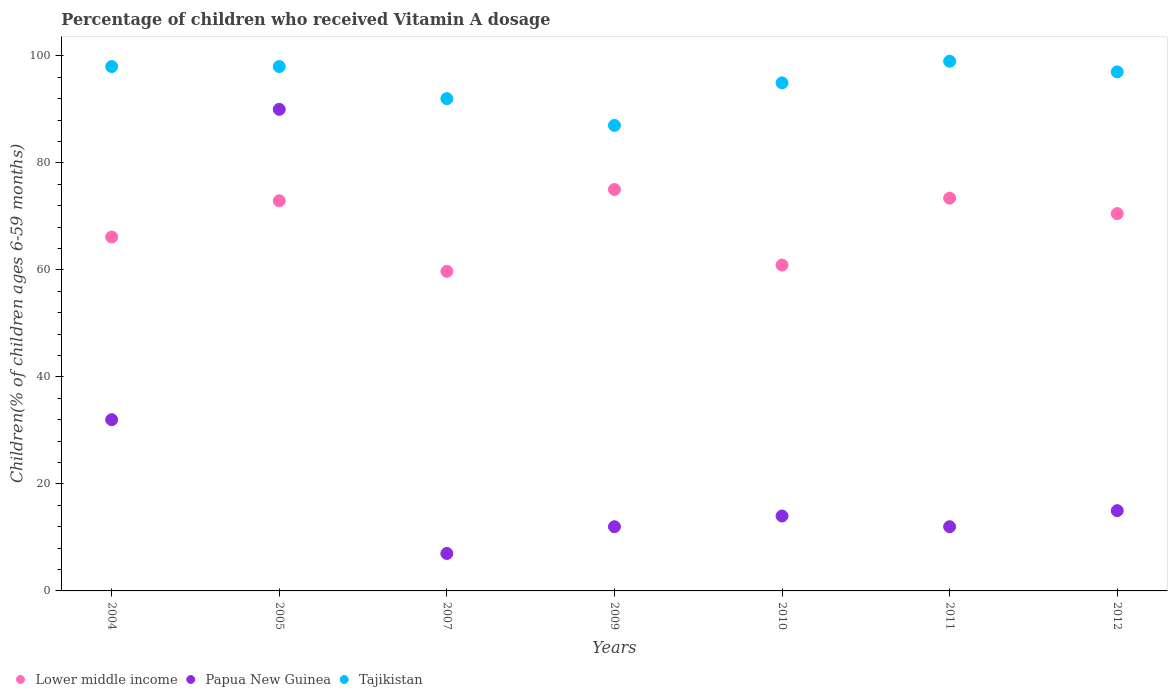What is the total percentage of children who received Vitamin A dosage in Papua New Guinea in the graph?
Provide a succinct answer. 182. What is the difference between the percentage of children who received Vitamin A dosage in Lower middle income in 2007 and that in 2012?
Ensure brevity in your answer.  -10.79. What is the difference between the percentage of children who received Vitamin A dosage in Papua New Guinea in 2011 and the percentage of children who received Vitamin A dosage in Tajikistan in 2007?
Ensure brevity in your answer.  -80. What is the average percentage of children who received Vitamin A dosage in Lower middle income per year?
Offer a terse response. 68.37. In how many years, is the percentage of children who received Vitamin A dosage in Tajikistan greater than 92 %?
Provide a short and direct response. 5. What is the ratio of the percentage of children who received Vitamin A dosage in Papua New Guinea in 2010 to that in 2012?
Provide a succinct answer. 0.93. Is the difference between the percentage of children who received Vitamin A dosage in Tajikistan in 2005 and 2010 greater than the difference between the percentage of children who received Vitamin A dosage in Papua New Guinea in 2005 and 2010?
Provide a short and direct response. No. What is the difference between the highest and the second highest percentage of children who received Vitamin A dosage in Lower middle income?
Your answer should be very brief. 1.62. What is the difference between the highest and the lowest percentage of children who received Vitamin A dosage in Papua New Guinea?
Offer a terse response. 83. In how many years, is the percentage of children who received Vitamin A dosage in Lower middle income greater than the average percentage of children who received Vitamin A dosage in Lower middle income taken over all years?
Your response must be concise. 4. Is the sum of the percentage of children who received Vitamin A dosage in Tajikistan in 2004 and 2010 greater than the maximum percentage of children who received Vitamin A dosage in Lower middle income across all years?
Your answer should be very brief. Yes. Is it the case that in every year, the sum of the percentage of children who received Vitamin A dosage in Tajikistan and percentage of children who received Vitamin A dosage in Lower middle income  is greater than the percentage of children who received Vitamin A dosage in Papua New Guinea?
Provide a succinct answer. Yes. Does the percentage of children who received Vitamin A dosage in Tajikistan monotonically increase over the years?
Provide a succinct answer. No. Is the percentage of children who received Vitamin A dosage in Papua New Guinea strictly greater than the percentage of children who received Vitamin A dosage in Lower middle income over the years?
Your answer should be compact. No. Is the percentage of children who received Vitamin A dosage in Tajikistan strictly less than the percentage of children who received Vitamin A dosage in Lower middle income over the years?
Ensure brevity in your answer.  No. How many dotlines are there?
Provide a succinct answer. 3. How many years are there in the graph?
Your answer should be compact. 7. Are the values on the major ticks of Y-axis written in scientific E-notation?
Give a very brief answer. No. Does the graph contain grids?
Your answer should be compact. No. Where does the legend appear in the graph?
Provide a short and direct response. Bottom left. What is the title of the graph?
Make the answer very short. Percentage of children who received Vitamin A dosage. Does "United Arab Emirates" appear as one of the legend labels in the graph?
Provide a succinct answer. No. What is the label or title of the X-axis?
Make the answer very short. Years. What is the label or title of the Y-axis?
Offer a terse response. Children(% of children ages 6-59 months). What is the Children(% of children ages 6-59 months) in Lower middle income in 2004?
Provide a succinct answer. 66.15. What is the Children(% of children ages 6-59 months) in Tajikistan in 2004?
Make the answer very short. 98. What is the Children(% of children ages 6-59 months) in Lower middle income in 2005?
Your answer should be compact. 72.92. What is the Children(% of children ages 6-59 months) in Lower middle income in 2007?
Your response must be concise. 59.72. What is the Children(% of children ages 6-59 months) of Papua New Guinea in 2007?
Provide a succinct answer. 7. What is the Children(% of children ages 6-59 months) in Tajikistan in 2007?
Offer a terse response. 92. What is the Children(% of children ages 6-59 months) in Lower middle income in 2009?
Make the answer very short. 75.02. What is the Children(% of children ages 6-59 months) of Lower middle income in 2010?
Give a very brief answer. 60.9. What is the Children(% of children ages 6-59 months) in Papua New Guinea in 2010?
Keep it short and to the point. 14. What is the Children(% of children ages 6-59 months) in Tajikistan in 2010?
Make the answer very short. 94.95. What is the Children(% of children ages 6-59 months) of Lower middle income in 2011?
Your response must be concise. 73.4. What is the Children(% of children ages 6-59 months) in Tajikistan in 2011?
Offer a terse response. 99. What is the Children(% of children ages 6-59 months) of Lower middle income in 2012?
Your response must be concise. 70.51. What is the Children(% of children ages 6-59 months) of Papua New Guinea in 2012?
Offer a terse response. 15. What is the Children(% of children ages 6-59 months) of Tajikistan in 2012?
Provide a short and direct response. 97. Across all years, what is the maximum Children(% of children ages 6-59 months) of Lower middle income?
Your response must be concise. 75.02. Across all years, what is the maximum Children(% of children ages 6-59 months) in Papua New Guinea?
Offer a terse response. 90. Across all years, what is the maximum Children(% of children ages 6-59 months) of Tajikistan?
Your answer should be compact. 99. Across all years, what is the minimum Children(% of children ages 6-59 months) in Lower middle income?
Your answer should be compact. 59.72. Across all years, what is the minimum Children(% of children ages 6-59 months) in Tajikistan?
Provide a short and direct response. 87. What is the total Children(% of children ages 6-59 months) in Lower middle income in the graph?
Make the answer very short. 478.62. What is the total Children(% of children ages 6-59 months) in Papua New Guinea in the graph?
Provide a short and direct response. 182. What is the total Children(% of children ages 6-59 months) in Tajikistan in the graph?
Your answer should be very brief. 665.95. What is the difference between the Children(% of children ages 6-59 months) in Lower middle income in 2004 and that in 2005?
Make the answer very short. -6.77. What is the difference between the Children(% of children ages 6-59 months) of Papua New Guinea in 2004 and that in 2005?
Offer a terse response. -58. What is the difference between the Children(% of children ages 6-59 months) of Tajikistan in 2004 and that in 2005?
Provide a short and direct response. 0. What is the difference between the Children(% of children ages 6-59 months) in Lower middle income in 2004 and that in 2007?
Make the answer very short. 6.43. What is the difference between the Children(% of children ages 6-59 months) of Papua New Guinea in 2004 and that in 2007?
Make the answer very short. 25. What is the difference between the Children(% of children ages 6-59 months) of Lower middle income in 2004 and that in 2009?
Your answer should be very brief. -8.88. What is the difference between the Children(% of children ages 6-59 months) of Tajikistan in 2004 and that in 2009?
Give a very brief answer. 11. What is the difference between the Children(% of children ages 6-59 months) of Lower middle income in 2004 and that in 2010?
Ensure brevity in your answer.  5.25. What is the difference between the Children(% of children ages 6-59 months) of Tajikistan in 2004 and that in 2010?
Offer a terse response. 3.05. What is the difference between the Children(% of children ages 6-59 months) of Lower middle income in 2004 and that in 2011?
Provide a succinct answer. -7.26. What is the difference between the Children(% of children ages 6-59 months) in Lower middle income in 2004 and that in 2012?
Ensure brevity in your answer.  -4.36. What is the difference between the Children(% of children ages 6-59 months) in Papua New Guinea in 2004 and that in 2012?
Make the answer very short. 17. What is the difference between the Children(% of children ages 6-59 months) of Lower middle income in 2005 and that in 2007?
Your response must be concise. 13.2. What is the difference between the Children(% of children ages 6-59 months) in Papua New Guinea in 2005 and that in 2007?
Offer a terse response. 83. What is the difference between the Children(% of children ages 6-59 months) of Tajikistan in 2005 and that in 2007?
Ensure brevity in your answer.  6. What is the difference between the Children(% of children ages 6-59 months) of Lower middle income in 2005 and that in 2009?
Your response must be concise. -2.11. What is the difference between the Children(% of children ages 6-59 months) in Tajikistan in 2005 and that in 2009?
Your response must be concise. 11. What is the difference between the Children(% of children ages 6-59 months) in Lower middle income in 2005 and that in 2010?
Offer a very short reply. 12.02. What is the difference between the Children(% of children ages 6-59 months) in Papua New Guinea in 2005 and that in 2010?
Your response must be concise. 76. What is the difference between the Children(% of children ages 6-59 months) in Tajikistan in 2005 and that in 2010?
Your response must be concise. 3.05. What is the difference between the Children(% of children ages 6-59 months) of Lower middle income in 2005 and that in 2011?
Your response must be concise. -0.49. What is the difference between the Children(% of children ages 6-59 months) of Tajikistan in 2005 and that in 2011?
Provide a succinct answer. -1. What is the difference between the Children(% of children ages 6-59 months) in Lower middle income in 2005 and that in 2012?
Provide a short and direct response. 2.41. What is the difference between the Children(% of children ages 6-59 months) in Papua New Guinea in 2005 and that in 2012?
Your response must be concise. 75. What is the difference between the Children(% of children ages 6-59 months) of Lower middle income in 2007 and that in 2009?
Keep it short and to the point. -15.3. What is the difference between the Children(% of children ages 6-59 months) of Lower middle income in 2007 and that in 2010?
Offer a very short reply. -1.18. What is the difference between the Children(% of children ages 6-59 months) in Tajikistan in 2007 and that in 2010?
Offer a very short reply. -2.95. What is the difference between the Children(% of children ages 6-59 months) in Lower middle income in 2007 and that in 2011?
Your response must be concise. -13.68. What is the difference between the Children(% of children ages 6-59 months) of Papua New Guinea in 2007 and that in 2011?
Offer a terse response. -5. What is the difference between the Children(% of children ages 6-59 months) of Tajikistan in 2007 and that in 2011?
Keep it short and to the point. -7. What is the difference between the Children(% of children ages 6-59 months) of Lower middle income in 2007 and that in 2012?
Ensure brevity in your answer.  -10.79. What is the difference between the Children(% of children ages 6-59 months) of Tajikistan in 2007 and that in 2012?
Offer a terse response. -5. What is the difference between the Children(% of children ages 6-59 months) of Lower middle income in 2009 and that in 2010?
Offer a very short reply. 14.13. What is the difference between the Children(% of children ages 6-59 months) of Papua New Guinea in 2009 and that in 2010?
Ensure brevity in your answer.  -2. What is the difference between the Children(% of children ages 6-59 months) in Tajikistan in 2009 and that in 2010?
Your response must be concise. -7.95. What is the difference between the Children(% of children ages 6-59 months) of Lower middle income in 2009 and that in 2011?
Offer a terse response. 1.62. What is the difference between the Children(% of children ages 6-59 months) of Papua New Guinea in 2009 and that in 2011?
Keep it short and to the point. 0. What is the difference between the Children(% of children ages 6-59 months) of Tajikistan in 2009 and that in 2011?
Make the answer very short. -12. What is the difference between the Children(% of children ages 6-59 months) in Lower middle income in 2009 and that in 2012?
Your response must be concise. 4.51. What is the difference between the Children(% of children ages 6-59 months) in Lower middle income in 2010 and that in 2011?
Offer a very short reply. -12.51. What is the difference between the Children(% of children ages 6-59 months) of Tajikistan in 2010 and that in 2011?
Offer a terse response. -4.05. What is the difference between the Children(% of children ages 6-59 months) in Lower middle income in 2010 and that in 2012?
Keep it short and to the point. -9.62. What is the difference between the Children(% of children ages 6-59 months) in Papua New Guinea in 2010 and that in 2012?
Your answer should be compact. -1. What is the difference between the Children(% of children ages 6-59 months) of Tajikistan in 2010 and that in 2012?
Keep it short and to the point. -2.05. What is the difference between the Children(% of children ages 6-59 months) in Lower middle income in 2011 and that in 2012?
Make the answer very short. 2.89. What is the difference between the Children(% of children ages 6-59 months) in Lower middle income in 2004 and the Children(% of children ages 6-59 months) in Papua New Guinea in 2005?
Give a very brief answer. -23.85. What is the difference between the Children(% of children ages 6-59 months) in Lower middle income in 2004 and the Children(% of children ages 6-59 months) in Tajikistan in 2005?
Ensure brevity in your answer.  -31.85. What is the difference between the Children(% of children ages 6-59 months) of Papua New Guinea in 2004 and the Children(% of children ages 6-59 months) of Tajikistan in 2005?
Offer a very short reply. -66. What is the difference between the Children(% of children ages 6-59 months) of Lower middle income in 2004 and the Children(% of children ages 6-59 months) of Papua New Guinea in 2007?
Your response must be concise. 59.15. What is the difference between the Children(% of children ages 6-59 months) in Lower middle income in 2004 and the Children(% of children ages 6-59 months) in Tajikistan in 2007?
Make the answer very short. -25.85. What is the difference between the Children(% of children ages 6-59 months) of Papua New Guinea in 2004 and the Children(% of children ages 6-59 months) of Tajikistan in 2007?
Provide a short and direct response. -60. What is the difference between the Children(% of children ages 6-59 months) of Lower middle income in 2004 and the Children(% of children ages 6-59 months) of Papua New Guinea in 2009?
Provide a short and direct response. 54.15. What is the difference between the Children(% of children ages 6-59 months) of Lower middle income in 2004 and the Children(% of children ages 6-59 months) of Tajikistan in 2009?
Ensure brevity in your answer.  -20.85. What is the difference between the Children(% of children ages 6-59 months) in Papua New Guinea in 2004 and the Children(% of children ages 6-59 months) in Tajikistan in 2009?
Your answer should be compact. -55. What is the difference between the Children(% of children ages 6-59 months) of Lower middle income in 2004 and the Children(% of children ages 6-59 months) of Papua New Guinea in 2010?
Keep it short and to the point. 52.15. What is the difference between the Children(% of children ages 6-59 months) of Lower middle income in 2004 and the Children(% of children ages 6-59 months) of Tajikistan in 2010?
Provide a short and direct response. -28.8. What is the difference between the Children(% of children ages 6-59 months) in Papua New Guinea in 2004 and the Children(% of children ages 6-59 months) in Tajikistan in 2010?
Ensure brevity in your answer.  -62.95. What is the difference between the Children(% of children ages 6-59 months) in Lower middle income in 2004 and the Children(% of children ages 6-59 months) in Papua New Guinea in 2011?
Offer a very short reply. 54.15. What is the difference between the Children(% of children ages 6-59 months) in Lower middle income in 2004 and the Children(% of children ages 6-59 months) in Tajikistan in 2011?
Your answer should be very brief. -32.85. What is the difference between the Children(% of children ages 6-59 months) in Papua New Guinea in 2004 and the Children(% of children ages 6-59 months) in Tajikistan in 2011?
Make the answer very short. -67. What is the difference between the Children(% of children ages 6-59 months) in Lower middle income in 2004 and the Children(% of children ages 6-59 months) in Papua New Guinea in 2012?
Your response must be concise. 51.15. What is the difference between the Children(% of children ages 6-59 months) of Lower middle income in 2004 and the Children(% of children ages 6-59 months) of Tajikistan in 2012?
Offer a very short reply. -30.85. What is the difference between the Children(% of children ages 6-59 months) of Papua New Guinea in 2004 and the Children(% of children ages 6-59 months) of Tajikistan in 2012?
Your answer should be very brief. -65. What is the difference between the Children(% of children ages 6-59 months) of Lower middle income in 2005 and the Children(% of children ages 6-59 months) of Papua New Guinea in 2007?
Your answer should be very brief. 65.92. What is the difference between the Children(% of children ages 6-59 months) of Lower middle income in 2005 and the Children(% of children ages 6-59 months) of Tajikistan in 2007?
Your answer should be compact. -19.08. What is the difference between the Children(% of children ages 6-59 months) in Lower middle income in 2005 and the Children(% of children ages 6-59 months) in Papua New Guinea in 2009?
Make the answer very short. 60.92. What is the difference between the Children(% of children ages 6-59 months) in Lower middle income in 2005 and the Children(% of children ages 6-59 months) in Tajikistan in 2009?
Your answer should be compact. -14.08. What is the difference between the Children(% of children ages 6-59 months) of Lower middle income in 2005 and the Children(% of children ages 6-59 months) of Papua New Guinea in 2010?
Ensure brevity in your answer.  58.92. What is the difference between the Children(% of children ages 6-59 months) of Lower middle income in 2005 and the Children(% of children ages 6-59 months) of Tajikistan in 2010?
Give a very brief answer. -22.03. What is the difference between the Children(% of children ages 6-59 months) in Papua New Guinea in 2005 and the Children(% of children ages 6-59 months) in Tajikistan in 2010?
Provide a short and direct response. -4.95. What is the difference between the Children(% of children ages 6-59 months) of Lower middle income in 2005 and the Children(% of children ages 6-59 months) of Papua New Guinea in 2011?
Provide a succinct answer. 60.92. What is the difference between the Children(% of children ages 6-59 months) in Lower middle income in 2005 and the Children(% of children ages 6-59 months) in Tajikistan in 2011?
Give a very brief answer. -26.08. What is the difference between the Children(% of children ages 6-59 months) of Papua New Guinea in 2005 and the Children(% of children ages 6-59 months) of Tajikistan in 2011?
Provide a short and direct response. -9. What is the difference between the Children(% of children ages 6-59 months) of Lower middle income in 2005 and the Children(% of children ages 6-59 months) of Papua New Guinea in 2012?
Provide a succinct answer. 57.92. What is the difference between the Children(% of children ages 6-59 months) in Lower middle income in 2005 and the Children(% of children ages 6-59 months) in Tajikistan in 2012?
Your response must be concise. -24.08. What is the difference between the Children(% of children ages 6-59 months) in Lower middle income in 2007 and the Children(% of children ages 6-59 months) in Papua New Guinea in 2009?
Your answer should be very brief. 47.72. What is the difference between the Children(% of children ages 6-59 months) of Lower middle income in 2007 and the Children(% of children ages 6-59 months) of Tajikistan in 2009?
Your response must be concise. -27.28. What is the difference between the Children(% of children ages 6-59 months) of Papua New Guinea in 2007 and the Children(% of children ages 6-59 months) of Tajikistan in 2009?
Your answer should be compact. -80. What is the difference between the Children(% of children ages 6-59 months) in Lower middle income in 2007 and the Children(% of children ages 6-59 months) in Papua New Guinea in 2010?
Provide a succinct answer. 45.72. What is the difference between the Children(% of children ages 6-59 months) in Lower middle income in 2007 and the Children(% of children ages 6-59 months) in Tajikistan in 2010?
Make the answer very short. -35.23. What is the difference between the Children(% of children ages 6-59 months) of Papua New Guinea in 2007 and the Children(% of children ages 6-59 months) of Tajikistan in 2010?
Ensure brevity in your answer.  -87.95. What is the difference between the Children(% of children ages 6-59 months) of Lower middle income in 2007 and the Children(% of children ages 6-59 months) of Papua New Guinea in 2011?
Give a very brief answer. 47.72. What is the difference between the Children(% of children ages 6-59 months) in Lower middle income in 2007 and the Children(% of children ages 6-59 months) in Tajikistan in 2011?
Give a very brief answer. -39.28. What is the difference between the Children(% of children ages 6-59 months) in Papua New Guinea in 2007 and the Children(% of children ages 6-59 months) in Tajikistan in 2011?
Offer a very short reply. -92. What is the difference between the Children(% of children ages 6-59 months) in Lower middle income in 2007 and the Children(% of children ages 6-59 months) in Papua New Guinea in 2012?
Your answer should be compact. 44.72. What is the difference between the Children(% of children ages 6-59 months) of Lower middle income in 2007 and the Children(% of children ages 6-59 months) of Tajikistan in 2012?
Offer a terse response. -37.28. What is the difference between the Children(% of children ages 6-59 months) in Papua New Guinea in 2007 and the Children(% of children ages 6-59 months) in Tajikistan in 2012?
Make the answer very short. -90. What is the difference between the Children(% of children ages 6-59 months) of Lower middle income in 2009 and the Children(% of children ages 6-59 months) of Papua New Guinea in 2010?
Provide a short and direct response. 61.02. What is the difference between the Children(% of children ages 6-59 months) in Lower middle income in 2009 and the Children(% of children ages 6-59 months) in Tajikistan in 2010?
Provide a short and direct response. -19.93. What is the difference between the Children(% of children ages 6-59 months) in Papua New Guinea in 2009 and the Children(% of children ages 6-59 months) in Tajikistan in 2010?
Offer a very short reply. -82.95. What is the difference between the Children(% of children ages 6-59 months) of Lower middle income in 2009 and the Children(% of children ages 6-59 months) of Papua New Guinea in 2011?
Offer a very short reply. 63.02. What is the difference between the Children(% of children ages 6-59 months) in Lower middle income in 2009 and the Children(% of children ages 6-59 months) in Tajikistan in 2011?
Offer a very short reply. -23.98. What is the difference between the Children(% of children ages 6-59 months) in Papua New Guinea in 2009 and the Children(% of children ages 6-59 months) in Tajikistan in 2011?
Provide a short and direct response. -87. What is the difference between the Children(% of children ages 6-59 months) in Lower middle income in 2009 and the Children(% of children ages 6-59 months) in Papua New Guinea in 2012?
Your answer should be very brief. 60.02. What is the difference between the Children(% of children ages 6-59 months) in Lower middle income in 2009 and the Children(% of children ages 6-59 months) in Tajikistan in 2012?
Offer a very short reply. -21.98. What is the difference between the Children(% of children ages 6-59 months) in Papua New Guinea in 2009 and the Children(% of children ages 6-59 months) in Tajikistan in 2012?
Offer a terse response. -85. What is the difference between the Children(% of children ages 6-59 months) of Lower middle income in 2010 and the Children(% of children ages 6-59 months) of Papua New Guinea in 2011?
Keep it short and to the point. 48.9. What is the difference between the Children(% of children ages 6-59 months) in Lower middle income in 2010 and the Children(% of children ages 6-59 months) in Tajikistan in 2011?
Your response must be concise. -38.1. What is the difference between the Children(% of children ages 6-59 months) in Papua New Guinea in 2010 and the Children(% of children ages 6-59 months) in Tajikistan in 2011?
Offer a very short reply. -85. What is the difference between the Children(% of children ages 6-59 months) in Lower middle income in 2010 and the Children(% of children ages 6-59 months) in Papua New Guinea in 2012?
Keep it short and to the point. 45.9. What is the difference between the Children(% of children ages 6-59 months) in Lower middle income in 2010 and the Children(% of children ages 6-59 months) in Tajikistan in 2012?
Make the answer very short. -36.1. What is the difference between the Children(% of children ages 6-59 months) of Papua New Guinea in 2010 and the Children(% of children ages 6-59 months) of Tajikistan in 2012?
Provide a short and direct response. -83. What is the difference between the Children(% of children ages 6-59 months) of Lower middle income in 2011 and the Children(% of children ages 6-59 months) of Papua New Guinea in 2012?
Ensure brevity in your answer.  58.4. What is the difference between the Children(% of children ages 6-59 months) in Lower middle income in 2011 and the Children(% of children ages 6-59 months) in Tajikistan in 2012?
Keep it short and to the point. -23.6. What is the difference between the Children(% of children ages 6-59 months) in Papua New Guinea in 2011 and the Children(% of children ages 6-59 months) in Tajikistan in 2012?
Provide a short and direct response. -85. What is the average Children(% of children ages 6-59 months) of Lower middle income per year?
Offer a terse response. 68.37. What is the average Children(% of children ages 6-59 months) of Papua New Guinea per year?
Your answer should be very brief. 26. What is the average Children(% of children ages 6-59 months) in Tajikistan per year?
Give a very brief answer. 95.14. In the year 2004, what is the difference between the Children(% of children ages 6-59 months) of Lower middle income and Children(% of children ages 6-59 months) of Papua New Guinea?
Keep it short and to the point. 34.15. In the year 2004, what is the difference between the Children(% of children ages 6-59 months) in Lower middle income and Children(% of children ages 6-59 months) in Tajikistan?
Provide a succinct answer. -31.85. In the year 2004, what is the difference between the Children(% of children ages 6-59 months) in Papua New Guinea and Children(% of children ages 6-59 months) in Tajikistan?
Ensure brevity in your answer.  -66. In the year 2005, what is the difference between the Children(% of children ages 6-59 months) of Lower middle income and Children(% of children ages 6-59 months) of Papua New Guinea?
Give a very brief answer. -17.08. In the year 2005, what is the difference between the Children(% of children ages 6-59 months) in Lower middle income and Children(% of children ages 6-59 months) in Tajikistan?
Offer a terse response. -25.08. In the year 2005, what is the difference between the Children(% of children ages 6-59 months) of Papua New Guinea and Children(% of children ages 6-59 months) of Tajikistan?
Offer a very short reply. -8. In the year 2007, what is the difference between the Children(% of children ages 6-59 months) of Lower middle income and Children(% of children ages 6-59 months) of Papua New Guinea?
Make the answer very short. 52.72. In the year 2007, what is the difference between the Children(% of children ages 6-59 months) of Lower middle income and Children(% of children ages 6-59 months) of Tajikistan?
Offer a terse response. -32.28. In the year 2007, what is the difference between the Children(% of children ages 6-59 months) of Papua New Guinea and Children(% of children ages 6-59 months) of Tajikistan?
Keep it short and to the point. -85. In the year 2009, what is the difference between the Children(% of children ages 6-59 months) of Lower middle income and Children(% of children ages 6-59 months) of Papua New Guinea?
Offer a very short reply. 63.02. In the year 2009, what is the difference between the Children(% of children ages 6-59 months) in Lower middle income and Children(% of children ages 6-59 months) in Tajikistan?
Your answer should be very brief. -11.98. In the year 2009, what is the difference between the Children(% of children ages 6-59 months) of Papua New Guinea and Children(% of children ages 6-59 months) of Tajikistan?
Your answer should be very brief. -75. In the year 2010, what is the difference between the Children(% of children ages 6-59 months) of Lower middle income and Children(% of children ages 6-59 months) of Papua New Guinea?
Give a very brief answer. 46.9. In the year 2010, what is the difference between the Children(% of children ages 6-59 months) of Lower middle income and Children(% of children ages 6-59 months) of Tajikistan?
Keep it short and to the point. -34.05. In the year 2010, what is the difference between the Children(% of children ages 6-59 months) in Papua New Guinea and Children(% of children ages 6-59 months) in Tajikistan?
Keep it short and to the point. -80.95. In the year 2011, what is the difference between the Children(% of children ages 6-59 months) in Lower middle income and Children(% of children ages 6-59 months) in Papua New Guinea?
Your answer should be very brief. 61.4. In the year 2011, what is the difference between the Children(% of children ages 6-59 months) of Lower middle income and Children(% of children ages 6-59 months) of Tajikistan?
Provide a short and direct response. -25.6. In the year 2011, what is the difference between the Children(% of children ages 6-59 months) in Papua New Guinea and Children(% of children ages 6-59 months) in Tajikistan?
Keep it short and to the point. -87. In the year 2012, what is the difference between the Children(% of children ages 6-59 months) in Lower middle income and Children(% of children ages 6-59 months) in Papua New Guinea?
Your answer should be compact. 55.51. In the year 2012, what is the difference between the Children(% of children ages 6-59 months) in Lower middle income and Children(% of children ages 6-59 months) in Tajikistan?
Give a very brief answer. -26.49. In the year 2012, what is the difference between the Children(% of children ages 6-59 months) of Papua New Guinea and Children(% of children ages 6-59 months) of Tajikistan?
Ensure brevity in your answer.  -82. What is the ratio of the Children(% of children ages 6-59 months) in Lower middle income in 2004 to that in 2005?
Keep it short and to the point. 0.91. What is the ratio of the Children(% of children ages 6-59 months) of Papua New Guinea in 2004 to that in 2005?
Keep it short and to the point. 0.36. What is the ratio of the Children(% of children ages 6-59 months) of Tajikistan in 2004 to that in 2005?
Give a very brief answer. 1. What is the ratio of the Children(% of children ages 6-59 months) in Lower middle income in 2004 to that in 2007?
Your response must be concise. 1.11. What is the ratio of the Children(% of children ages 6-59 months) in Papua New Guinea in 2004 to that in 2007?
Provide a short and direct response. 4.57. What is the ratio of the Children(% of children ages 6-59 months) of Tajikistan in 2004 to that in 2007?
Your answer should be compact. 1.07. What is the ratio of the Children(% of children ages 6-59 months) in Lower middle income in 2004 to that in 2009?
Your answer should be compact. 0.88. What is the ratio of the Children(% of children ages 6-59 months) of Papua New Guinea in 2004 to that in 2009?
Give a very brief answer. 2.67. What is the ratio of the Children(% of children ages 6-59 months) in Tajikistan in 2004 to that in 2009?
Ensure brevity in your answer.  1.13. What is the ratio of the Children(% of children ages 6-59 months) of Lower middle income in 2004 to that in 2010?
Make the answer very short. 1.09. What is the ratio of the Children(% of children ages 6-59 months) of Papua New Guinea in 2004 to that in 2010?
Give a very brief answer. 2.29. What is the ratio of the Children(% of children ages 6-59 months) of Tajikistan in 2004 to that in 2010?
Keep it short and to the point. 1.03. What is the ratio of the Children(% of children ages 6-59 months) of Lower middle income in 2004 to that in 2011?
Ensure brevity in your answer.  0.9. What is the ratio of the Children(% of children ages 6-59 months) in Papua New Guinea in 2004 to that in 2011?
Provide a succinct answer. 2.67. What is the ratio of the Children(% of children ages 6-59 months) in Lower middle income in 2004 to that in 2012?
Keep it short and to the point. 0.94. What is the ratio of the Children(% of children ages 6-59 months) of Papua New Guinea in 2004 to that in 2012?
Your answer should be very brief. 2.13. What is the ratio of the Children(% of children ages 6-59 months) in Tajikistan in 2004 to that in 2012?
Keep it short and to the point. 1.01. What is the ratio of the Children(% of children ages 6-59 months) of Lower middle income in 2005 to that in 2007?
Ensure brevity in your answer.  1.22. What is the ratio of the Children(% of children ages 6-59 months) of Papua New Guinea in 2005 to that in 2007?
Provide a succinct answer. 12.86. What is the ratio of the Children(% of children ages 6-59 months) of Tajikistan in 2005 to that in 2007?
Give a very brief answer. 1.07. What is the ratio of the Children(% of children ages 6-59 months) of Lower middle income in 2005 to that in 2009?
Make the answer very short. 0.97. What is the ratio of the Children(% of children ages 6-59 months) of Tajikistan in 2005 to that in 2009?
Ensure brevity in your answer.  1.13. What is the ratio of the Children(% of children ages 6-59 months) of Lower middle income in 2005 to that in 2010?
Keep it short and to the point. 1.2. What is the ratio of the Children(% of children ages 6-59 months) of Papua New Guinea in 2005 to that in 2010?
Your answer should be compact. 6.43. What is the ratio of the Children(% of children ages 6-59 months) in Tajikistan in 2005 to that in 2010?
Make the answer very short. 1.03. What is the ratio of the Children(% of children ages 6-59 months) in Papua New Guinea in 2005 to that in 2011?
Provide a short and direct response. 7.5. What is the ratio of the Children(% of children ages 6-59 months) in Tajikistan in 2005 to that in 2011?
Ensure brevity in your answer.  0.99. What is the ratio of the Children(% of children ages 6-59 months) of Lower middle income in 2005 to that in 2012?
Provide a succinct answer. 1.03. What is the ratio of the Children(% of children ages 6-59 months) in Papua New Guinea in 2005 to that in 2012?
Ensure brevity in your answer.  6. What is the ratio of the Children(% of children ages 6-59 months) in Tajikistan in 2005 to that in 2012?
Provide a short and direct response. 1.01. What is the ratio of the Children(% of children ages 6-59 months) of Lower middle income in 2007 to that in 2009?
Ensure brevity in your answer.  0.8. What is the ratio of the Children(% of children ages 6-59 months) of Papua New Guinea in 2007 to that in 2009?
Make the answer very short. 0.58. What is the ratio of the Children(% of children ages 6-59 months) in Tajikistan in 2007 to that in 2009?
Your answer should be very brief. 1.06. What is the ratio of the Children(% of children ages 6-59 months) of Lower middle income in 2007 to that in 2010?
Offer a terse response. 0.98. What is the ratio of the Children(% of children ages 6-59 months) of Papua New Guinea in 2007 to that in 2010?
Ensure brevity in your answer.  0.5. What is the ratio of the Children(% of children ages 6-59 months) in Tajikistan in 2007 to that in 2010?
Offer a terse response. 0.97. What is the ratio of the Children(% of children ages 6-59 months) in Lower middle income in 2007 to that in 2011?
Your answer should be very brief. 0.81. What is the ratio of the Children(% of children ages 6-59 months) of Papua New Guinea in 2007 to that in 2011?
Your answer should be compact. 0.58. What is the ratio of the Children(% of children ages 6-59 months) of Tajikistan in 2007 to that in 2011?
Provide a short and direct response. 0.93. What is the ratio of the Children(% of children ages 6-59 months) of Lower middle income in 2007 to that in 2012?
Your answer should be compact. 0.85. What is the ratio of the Children(% of children ages 6-59 months) in Papua New Guinea in 2007 to that in 2012?
Your response must be concise. 0.47. What is the ratio of the Children(% of children ages 6-59 months) of Tajikistan in 2007 to that in 2012?
Give a very brief answer. 0.95. What is the ratio of the Children(% of children ages 6-59 months) of Lower middle income in 2009 to that in 2010?
Your answer should be very brief. 1.23. What is the ratio of the Children(% of children ages 6-59 months) of Papua New Guinea in 2009 to that in 2010?
Your response must be concise. 0.86. What is the ratio of the Children(% of children ages 6-59 months) of Tajikistan in 2009 to that in 2010?
Make the answer very short. 0.92. What is the ratio of the Children(% of children ages 6-59 months) of Lower middle income in 2009 to that in 2011?
Provide a succinct answer. 1.02. What is the ratio of the Children(% of children ages 6-59 months) of Papua New Guinea in 2009 to that in 2011?
Your response must be concise. 1. What is the ratio of the Children(% of children ages 6-59 months) in Tajikistan in 2009 to that in 2011?
Give a very brief answer. 0.88. What is the ratio of the Children(% of children ages 6-59 months) of Lower middle income in 2009 to that in 2012?
Offer a terse response. 1.06. What is the ratio of the Children(% of children ages 6-59 months) of Papua New Guinea in 2009 to that in 2012?
Offer a very short reply. 0.8. What is the ratio of the Children(% of children ages 6-59 months) of Tajikistan in 2009 to that in 2012?
Your response must be concise. 0.9. What is the ratio of the Children(% of children ages 6-59 months) in Lower middle income in 2010 to that in 2011?
Provide a succinct answer. 0.83. What is the ratio of the Children(% of children ages 6-59 months) in Papua New Guinea in 2010 to that in 2011?
Keep it short and to the point. 1.17. What is the ratio of the Children(% of children ages 6-59 months) of Tajikistan in 2010 to that in 2011?
Offer a terse response. 0.96. What is the ratio of the Children(% of children ages 6-59 months) of Lower middle income in 2010 to that in 2012?
Your answer should be very brief. 0.86. What is the ratio of the Children(% of children ages 6-59 months) in Tajikistan in 2010 to that in 2012?
Provide a succinct answer. 0.98. What is the ratio of the Children(% of children ages 6-59 months) in Lower middle income in 2011 to that in 2012?
Provide a short and direct response. 1.04. What is the ratio of the Children(% of children ages 6-59 months) of Tajikistan in 2011 to that in 2012?
Keep it short and to the point. 1.02. What is the difference between the highest and the second highest Children(% of children ages 6-59 months) in Lower middle income?
Keep it short and to the point. 1.62. What is the difference between the highest and the second highest Children(% of children ages 6-59 months) of Papua New Guinea?
Your response must be concise. 58. What is the difference between the highest and the lowest Children(% of children ages 6-59 months) of Lower middle income?
Give a very brief answer. 15.3. 